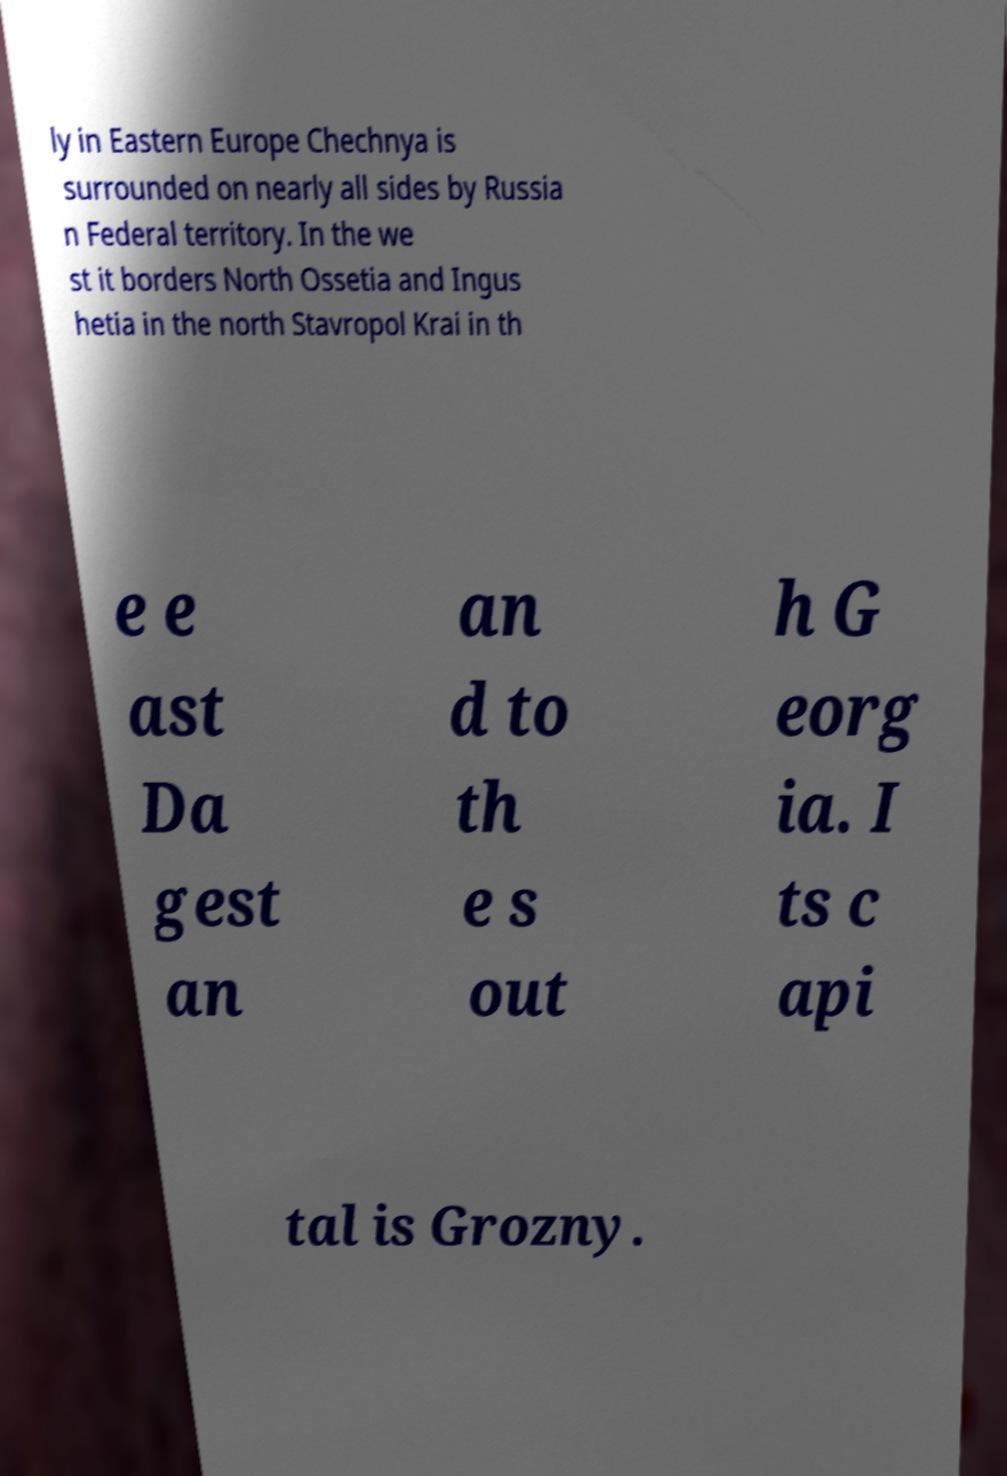Could you extract and type out the text from this image? ly in Eastern Europe Chechnya is surrounded on nearly all sides by Russia n Federal territory. In the we st it borders North Ossetia and Ingus hetia in the north Stavropol Krai in th e e ast Da gest an an d to th e s out h G eorg ia. I ts c api tal is Grozny. 